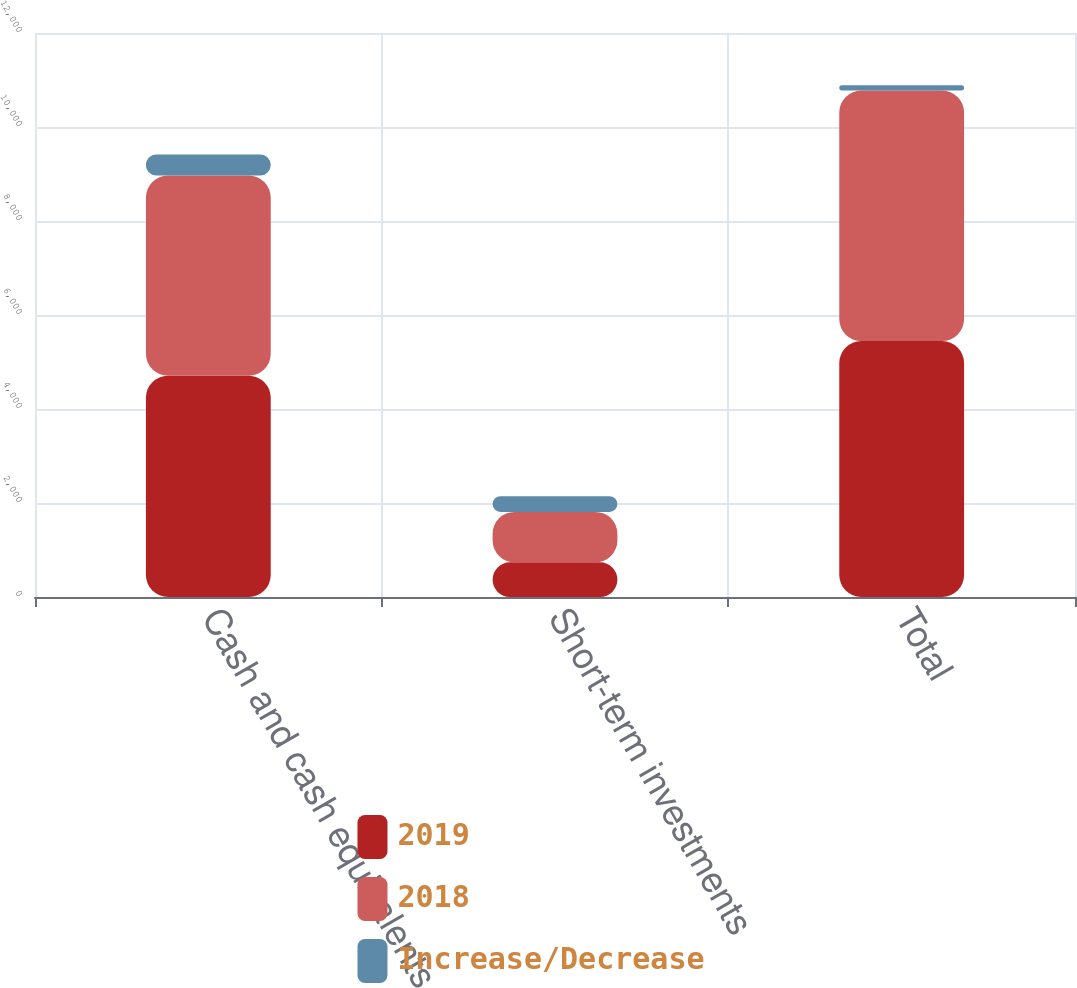<chart> <loc_0><loc_0><loc_500><loc_500><stacked_bar_chart><ecel><fcel>Cash and cash equivalents<fcel>Short-term investments<fcel>Total<nl><fcel>2019<fcel>4708<fcel>737<fcel>5445<nl><fcel>2018<fcel>4258<fcel>1073<fcel>5331<nl><fcel>Increase/Decrease<fcel>450<fcel>336<fcel>114<nl></chart> 